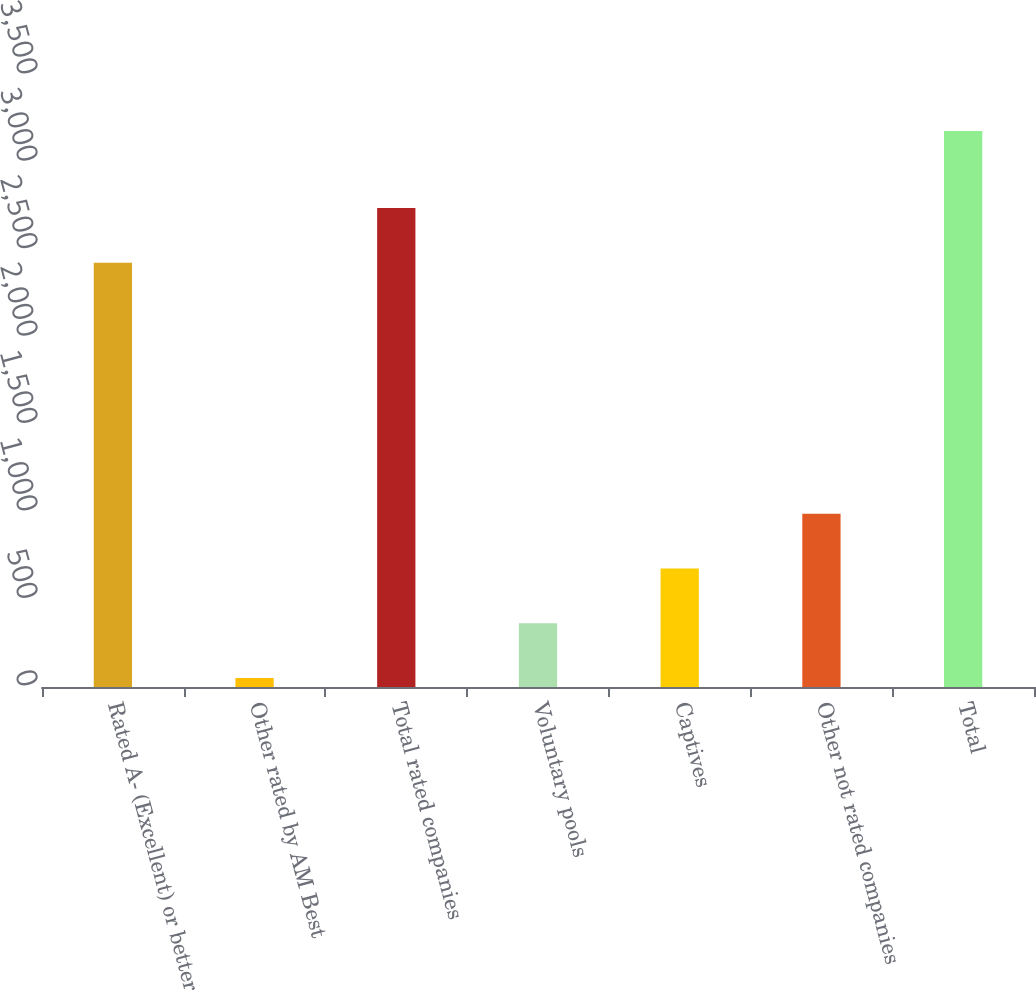Convert chart to OTSL. <chart><loc_0><loc_0><loc_500><loc_500><bar_chart><fcel>Rated A- (Excellent) or better<fcel>Other rated by AM Best<fcel>Total rated companies<fcel>Voluntary pools<fcel>Captives<fcel>Other not rated companies<fcel>Total<nl><fcel>2426<fcel>52<fcel>2738.8<fcel>364.8<fcel>677.6<fcel>990.4<fcel>3180<nl></chart> 